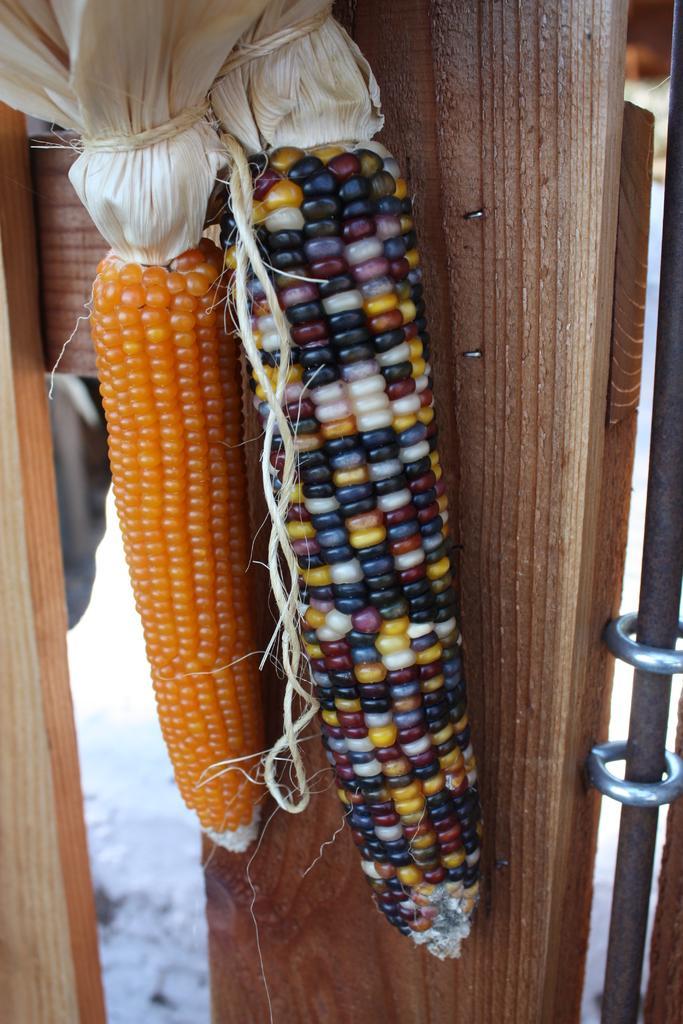Can you describe this image briefly? In this image I can see two corns where one is of orange color and one is of different colors. 